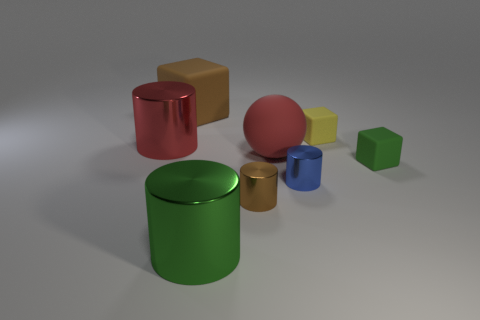Subtract all big red metallic cylinders. How many cylinders are left? 3 Subtract all red cylinders. How many cylinders are left? 3 Subtract 1 blocks. How many blocks are left? 2 Add 1 big red things. How many objects exist? 9 Subtract all yellow cylinders. Subtract all blue balls. How many cylinders are left? 4 Subtract all balls. How many objects are left? 7 Subtract all large yellow things. Subtract all tiny green blocks. How many objects are left? 7 Add 8 red objects. How many red objects are left? 10 Add 1 large red cylinders. How many large red cylinders exist? 2 Subtract 0 yellow cylinders. How many objects are left? 8 